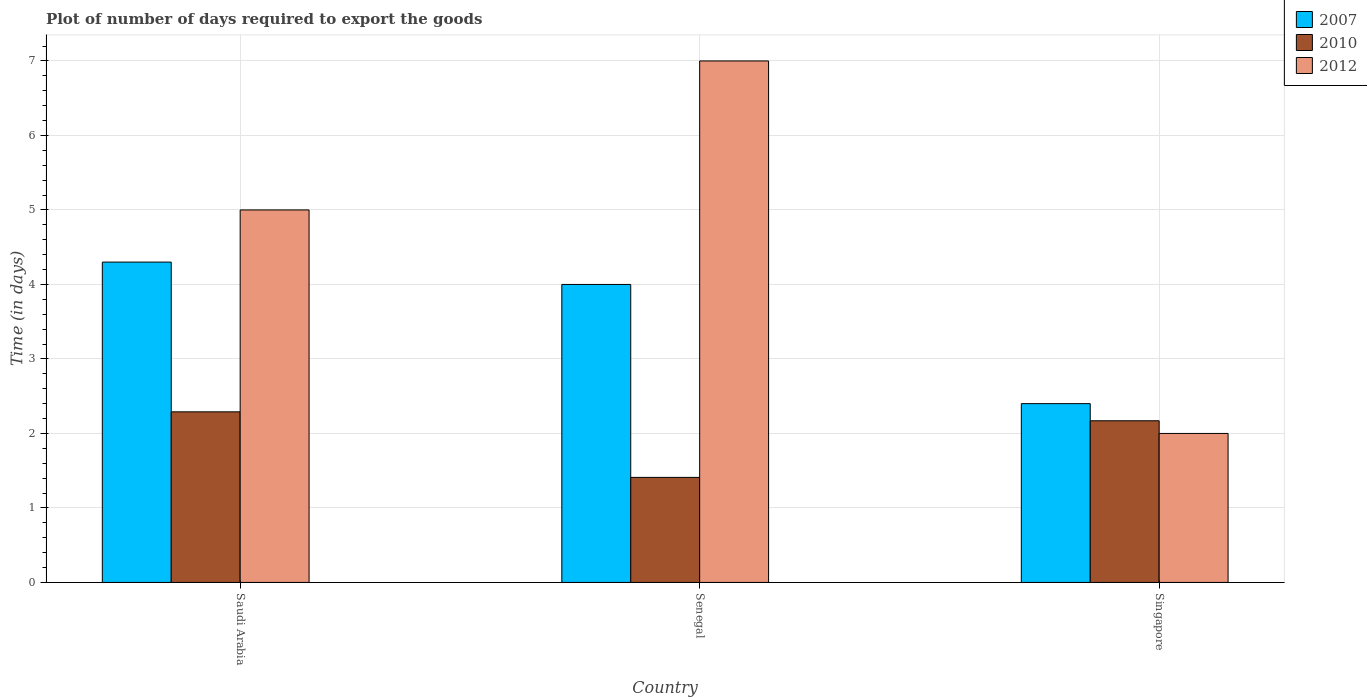How many different coloured bars are there?
Keep it short and to the point. 3. How many groups of bars are there?
Your answer should be compact. 3. Are the number of bars on each tick of the X-axis equal?
Your response must be concise. Yes. What is the label of the 3rd group of bars from the left?
Your answer should be very brief. Singapore. In how many cases, is the number of bars for a given country not equal to the number of legend labels?
Provide a short and direct response. 0. What is the time required to export goods in 2007 in Singapore?
Your answer should be very brief. 2.4. Across all countries, what is the maximum time required to export goods in 2012?
Offer a very short reply. 7. In which country was the time required to export goods in 2012 maximum?
Provide a short and direct response. Senegal. In which country was the time required to export goods in 2012 minimum?
Your answer should be very brief. Singapore. What is the total time required to export goods in 2007 in the graph?
Your answer should be compact. 10.7. What is the difference between the time required to export goods in 2010 in Saudi Arabia and that in Senegal?
Offer a terse response. 0.88. What is the difference between the time required to export goods in 2012 in Senegal and the time required to export goods in 2010 in Singapore?
Your answer should be very brief. 4.83. What is the average time required to export goods in 2007 per country?
Keep it short and to the point. 3.57. What is the difference between the time required to export goods of/in 2010 and time required to export goods of/in 2007 in Senegal?
Ensure brevity in your answer.  -2.59. What is the ratio of the time required to export goods in 2010 in Saudi Arabia to that in Singapore?
Give a very brief answer. 1.06. Is the time required to export goods in 2010 in Senegal less than that in Singapore?
Ensure brevity in your answer.  Yes. Is the difference between the time required to export goods in 2010 in Saudi Arabia and Singapore greater than the difference between the time required to export goods in 2007 in Saudi Arabia and Singapore?
Keep it short and to the point. No. What is the difference between the highest and the second highest time required to export goods in 2012?
Ensure brevity in your answer.  -3. What is the difference between the highest and the lowest time required to export goods in 2010?
Provide a short and direct response. 0.88. In how many countries, is the time required to export goods in 2012 greater than the average time required to export goods in 2012 taken over all countries?
Offer a terse response. 2. What does the 1st bar from the left in Singapore represents?
Give a very brief answer. 2007. What does the 1st bar from the right in Senegal represents?
Your response must be concise. 2012. Is it the case that in every country, the sum of the time required to export goods in 2010 and time required to export goods in 2012 is greater than the time required to export goods in 2007?
Your answer should be very brief. Yes. Are all the bars in the graph horizontal?
Offer a terse response. No. How many countries are there in the graph?
Your answer should be compact. 3. Are the values on the major ticks of Y-axis written in scientific E-notation?
Give a very brief answer. No. Does the graph contain any zero values?
Your response must be concise. No. Where does the legend appear in the graph?
Make the answer very short. Top right. How many legend labels are there?
Offer a terse response. 3. How are the legend labels stacked?
Your answer should be compact. Vertical. What is the title of the graph?
Make the answer very short. Plot of number of days required to export the goods. Does "1973" appear as one of the legend labels in the graph?
Give a very brief answer. No. What is the label or title of the X-axis?
Provide a succinct answer. Country. What is the label or title of the Y-axis?
Keep it short and to the point. Time (in days). What is the Time (in days) of 2007 in Saudi Arabia?
Offer a very short reply. 4.3. What is the Time (in days) in 2010 in Saudi Arabia?
Your answer should be very brief. 2.29. What is the Time (in days) of 2012 in Saudi Arabia?
Provide a succinct answer. 5. What is the Time (in days) of 2007 in Senegal?
Offer a terse response. 4. What is the Time (in days) of 2010 in Senegal?
Ensure brevity in your answer.  1.41. What is the Time (in days) of 2012 in Senegal?
Provide a succinct answer. 7. What is the Time (in days) in 2007 in Singapore?
Your response must be concise. 2.4. What is the Time (in days) in 2010 in Singapore?
Your answer should be compact. 2.17. What is the Time (in days) in 2012 in Singapore?
Make the answer very short. 2. Across all countries, what is the maximum Time (in days) in 2007?
Give a very brief answer. 4.3. Across all countries, what is the maximum Time (in days) in 2010?
Ensure brevity in your answer.  2.29. Across all countries, what is the minimum Time (in days) of 2010?
Your answer should be compact. 1.41. What is the total Time (in days) in 2010 in the graph?
Your response must be concise. 5.87. What is the difference between the Time (in days) of 2010 in Saudi Arabia and that in Senegal?
Offer a very short reply. 0.88. What is the difference between the Time (in days) in 2007 in Saudi Arabia and that in Singapore?
Your answer should be very brief. 1.9. What is the difference between the Time (in days) of 2010 in Saudi Arabia and that in Singapore?
Your answer should be very brief. 0.12. What is the difference between the Time (in days) of 2012 in Saudi Arabia and that in Singapore?
Your response must be concise. 3. What is the difference between the Time (in days) of 2010 in Senegal and that in Singapore?
Provide a succinct answer. -0.76. What is the difference between the Time (in days) of 2007 in Saudi Arabia and the Time (in days) of 2010 in Senegal?
Offer a very short reply. 2.89. What is the difference between the Time (in days) of 2010 in Saudi Arabia and the Time (in days) of 2012 in Senegal?
Give a very brief answer. -4.71. What is the difference between the Time (in days) of 2007 in Saudi Arabia and the Time (in days) of 2010 in Singapore?
Ensure brevity in your answer.  2.13. What is the difference between the Time (in days) in 2010 in Saudi Arabia and the Time (in days) in 2012 in Singapore?
Offer a very short reply. 0.29. What is the difference between the Time (in days) in 2007 in Senegal and the Time (in days) in 2010 in Singapore?
Ensure brevity in your answer.  1.83. What is the difference between the Time (in days) in 2007 in Senegal and the Time (in days) in 2012 in Singapore?
Ensure brevity in your answer.  2. What is the difference between the Time (in days) in 2010 in Senegal and the Time (in days) in 2012 in Singapore?
Provide a succinct answer. -0.59. What is the average Time (in days) in 2007 per country?
Offer a terse response. 3.57. What is the average Time (in days) of 2010 per country?
Ensure brevity in your answer.  1.96. What is the average Time (in days) in 2012 per country?
Your response must be concise. 4.67. What is the difference between the Time (in days) of 2007 and Time (in days) of 2010 in Saudi Arabia?
Provide a succinct answer. 2.01. What is the difference between the Time (in days) of 2007 and Time (in days) of 2012 in Saudi Arabia?
Provide a succinct answer. -0.7. What is the difference between the Time (in days) in 2010 and Time (in days) in 2012 in Saudi Arabia?
Provide a succinct answer. -2.71. What is the difference between the Time (in days) of 2007 and Time (in days) of 2010 in Senegal?
Offer a terse response. 2.59. What is the difference between the Time (in days) of 2007 and Time (in days) of 2012 in Senegal?
Your response must be concise. -3. What is the difference between the Time (in days) of 2010 and Time (in days) of 2012 in Senegal?
Make the answer very short. -5.59. What is the difference between the Time (in days) of 2007 and Time (in days) of 2010 in Singapore?
Keep it short and to the point. 0.23. What is the difference between the Time (in days) in 2007 and Time (in days) in 2012 in Singapore?
Ensure brevity in your answer.  0.4. What is the difference between the Time (in days) in 2010 and Time (in days) in 2012 in Singapore?
Provide a short and direct response. 0.17. What is the ratio of the Time (in days) in 2007 in Saudi Arabia to that in Senegal?
Keep it short and to the point. 1.07. What is the ratio of the Time (in days) of 2010 in Saudi Arabia to that in Senegal?
Provide a succinct answer. 1.62. What is the ratio of the Time (in days) in 2007 in Saudi Arabia to that in Singapore?
Provide a succinct answer. 1.79. What is the ratio of the Time (in days) in 2010 in Saudi Arabia to that in Singapore?
Your answer should be compact. 1.06. What is the ratio of the Time (in days) of 2007 in Senegal to that in Singapore?
Make the answer very short. 1.67. What is the ratio of the Time (in days) of 2010 in Senegal to that in Singapore?
Your answer should be very brief. 0.65. What is the ratio of the Time (in days) in 2012 in Senegal to that in Singapore?
Provide a short and direct response. 3.5. What is the difference between the highest and the second highest Time (in days) of 2010?
Keep it short and to the point. 0.12. What is the difference between the highest and the second highest Time (in days) in 2012?
Keep it short and to the point. 2. What is the difference between the highest and the lowest Time (in days) in 2007?
Make the answer very short. 1.9. What is the difference between the highest and the lowest Time (in days) in 2012?
Keep it short and to the point. 5. 